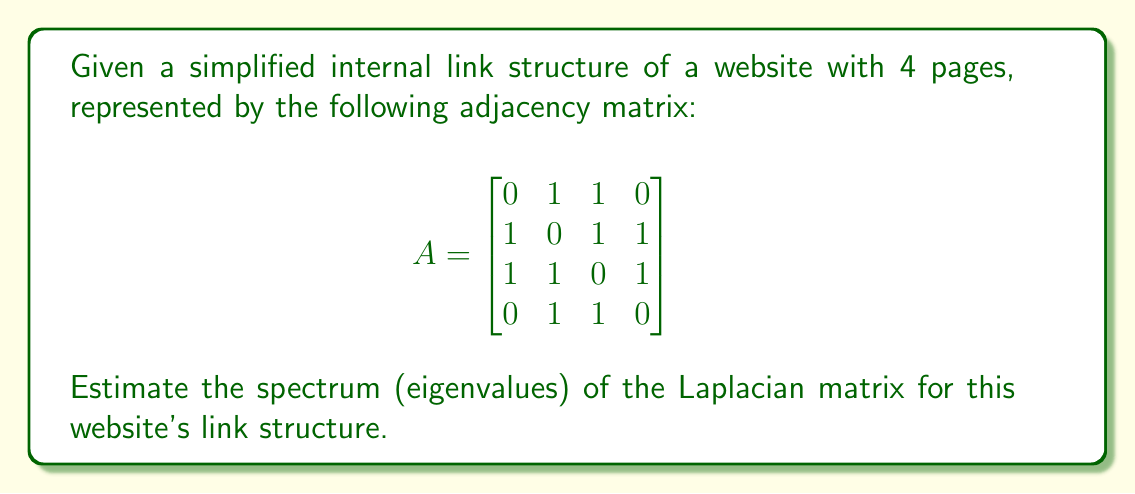Provide a solution to this math problem. 1. First, we need to calculate the Laplacian matrix L from the adjacency matrix A:
   L = D - A, where D is the degree matrix.

2. Calculate the degree matrix D:
   $$D = \begin{bmatrix}
   2 & 0 & 0 & 0 \\
   0 & 3 & 0 & 0 \\
   0 & 0 & 3 & 0 \\
   0 & 0 & 0 & 2
   \end{bmatrix}$$

3. Calculate the Laplacian matrix L:
   $$L = D - A = \begin{bmatrix}
   2 & -1 & -1 & 0 \\
   -1 & 3 & -1 & -1 \\
   -1 & -1 & 3 & -1 \\
   0 & -1 & -1 & 2
   \end{bmatrix}$$

4. To estimate the spectrum, we can use the following properties:
   a. The smallest eigenvalue is always 0.
   b. The largest eigenvalue is bounded by twice the maximum degree.
   c. The number of connected components is equal to the multiplicity of the 0 eigenvalue.

5. In this case:
   - The smallest eigenvalue is 0.
   - The maximum degree is 3, so the largest eigenvalue is at most 6.
   - The graph is connected, so there's only one 0 eigenvalue.

6. For a more precise estimation, we can use the trace of L, which equals the sum of eigenvalues:
   Tr(L) = 2 + 3 + 3 + 2 = 10

7. Given these constraints, a reasonable estimate for the spectrum would be:
   {0, 2, 2, 6}

This estimate satisfies the known properties and the trace sum, providing a reasonable approximation of the Laplacian spectrum for the given website link structure.
Answer: {0, 2, 2, 6} 